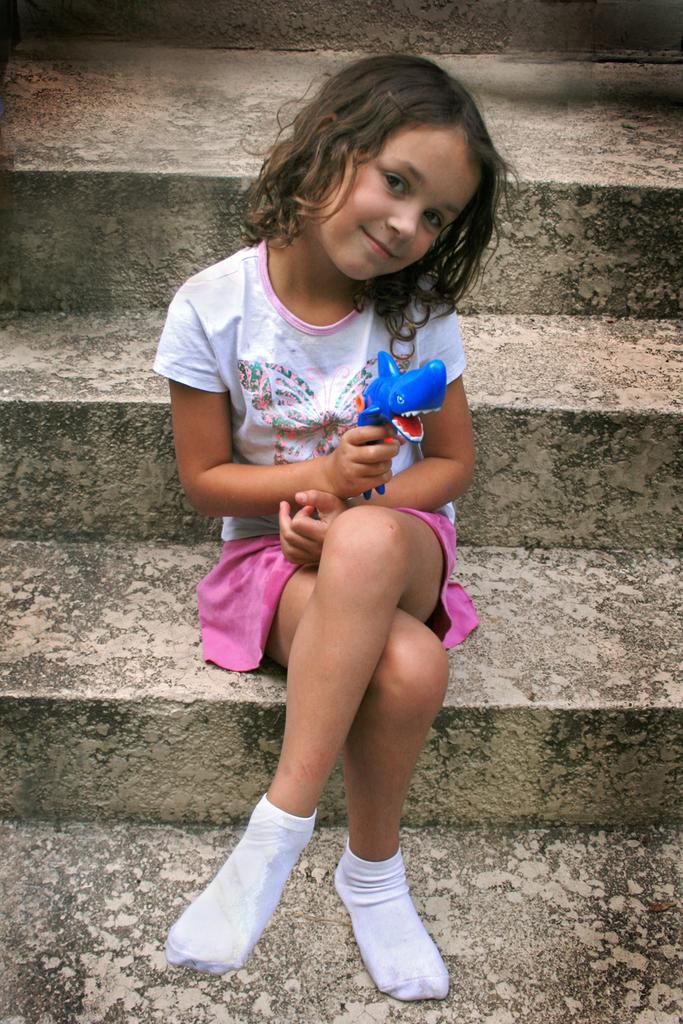Who is the main subject in the picture? There is a girl in the picture. What is the girl doing in the image? The girl is sitting on the stairs. What is the girl wearing in the image? The girl is wearing a white shirt and a pink shirt. What object is the girl holding in the image? The girl is holding a doll. What type of fuel is the girl using to power her toy car in the image? There is no toy car present in the image, so it is not possible to determine what type of fuel might be used. 